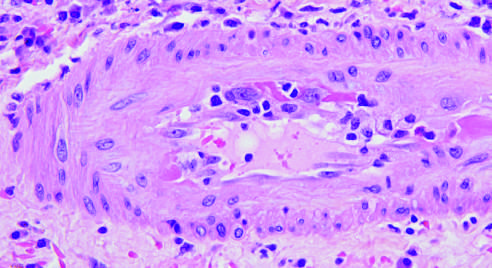s a section of an involved lacrimal gland shown with inflammatory cells attacking and undermining the endothelium arrow?
Answer the question using a single word or phrase. No 